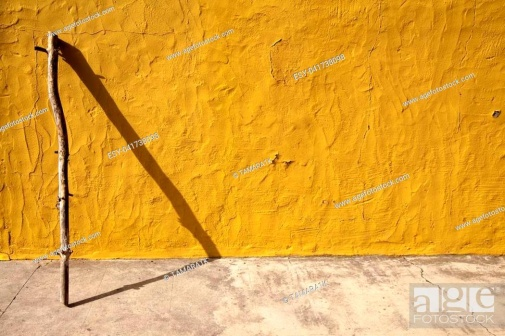If this image were a part of a story, what would be the plot? In a quiet, sunlit village, an old walking stick leans against a vibrant yellow wall, a symbol of countless journeys. This unassuming object witnesses the village's daily life – children playing, villagers chatting, seasons changing. One day, a curious child discovers the stick's hidden inscription, revealing clues to a forgotten adventure. The stick, once a traveler's loyal companion, becomes the catalyst for a new quest, unraveling the village's buried secrets and inspiring tales of bravery and discovery. 